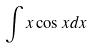<formula> <loc_0><loc_0><loc_500><loc_500>\int x \cos x d x</formula> 